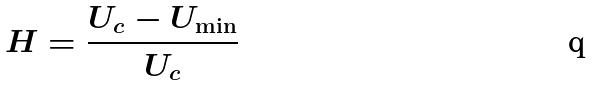Convert formula to latex. <formula><loc_0><loc_0><loc_500><loc_500>H = \frac { U _ { c } - U _ { \min } } { U _ { c } }</formula> 